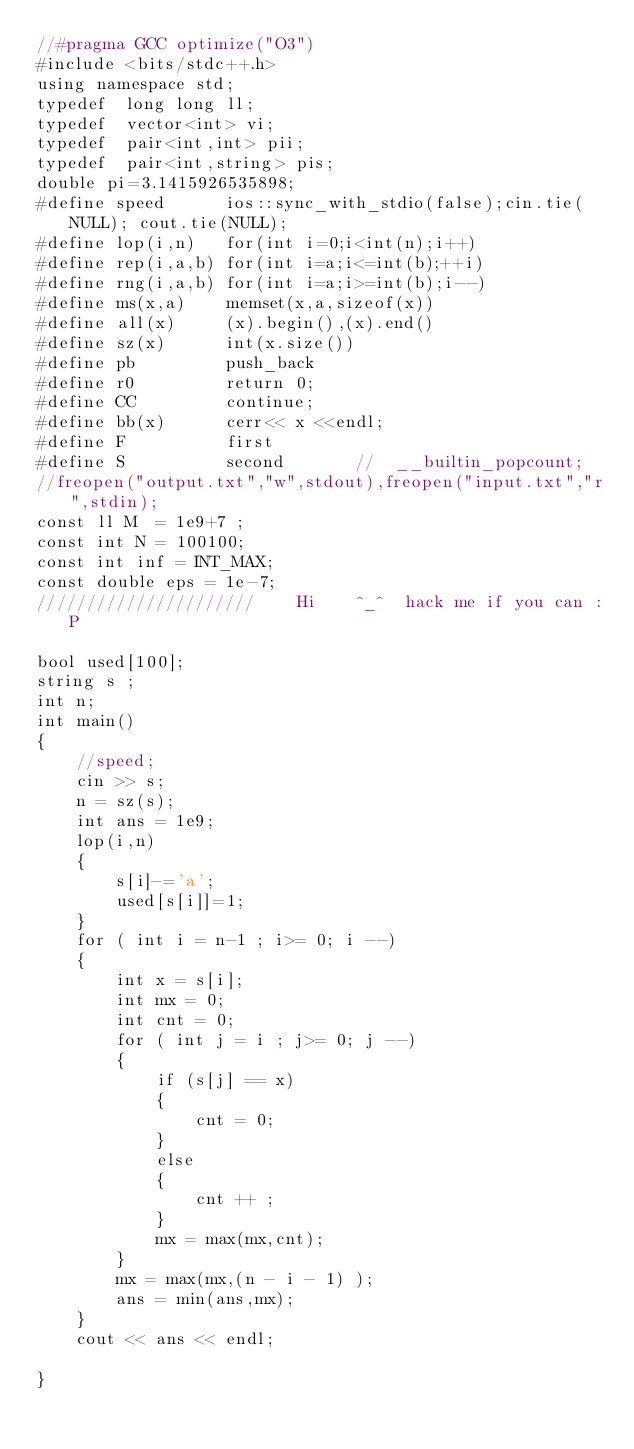<code> <loc_0><loc_0><loc_500><loc_500><_C++_>//#pragma GCC optimize("O3")
#include <bits/stdc++.h>
using namespace std;
typedef  long long ll;
typedef  vector<int> vi;
typedef  pair<int,int> pii;
typedef  pair<int,string> pis;
double pi=3.1415926535898;
#define speed      ios::sync_with_stdio(false);cin.tie(NULL); cout.tie(NULL);
#define lop(i,n)   for(int i=0;i<int(n);i++)
#define rep(i,a,b) for(int i=a;i<=int(b);++i)
#define rng(i,a,b) for(int i=a;i>=int(b);i--)
#define ms(x,a)    memset(x,a,sizeof(x))
#define all(x)     (x).begin(),(x).end()
#define sz(x)      int(x.size())
#define pb         push_back
#define r0         return 0;
#define CC         continue;
#define bb(x)      cerr<< x <<endl;
#define F          first
#define S          second       //  __builtin_popcount;
//freopen("output.txt","w",stdout),freopen("input.txt","r",stdin);
const ll M  = 1e9+7 ;
const int N = 100100;
const int inf = INT_MAX;
const double eps = 1e-7;
//////////////////////    Hi    ^_^  hack me if you can :P

bool used[100];
string s ;
int n;
int main()
{
    //speed;
    cin >> s;
    n = sz(s);
    int ans = 1e9;
    lop(i,n)
    {
        s[i]-='a';
        used[s[i]]=1;
    }
    for ( int i = n-1 ; i>= 0; i --)
    {
        int x = s[i];
        int mx = 0;
        int cnt = 0;
        for ( int j = i ; j>= 0; j --)
        {
            if (s[j] == x)
            {
                cnt = 0;
            }
            else
            {
                cnt ++ ;
            }
            mx = max(mx,cnt);
        }
        mx = max(mx,(n - i - 1) );
        ans = min(ans,mx);
    }
    cout << ans << endl;

}
</code> 